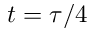Convert formula to latex. <formula><loc_0><loc_0><loc_500><loc_500>t = \tau / 4</formula> 